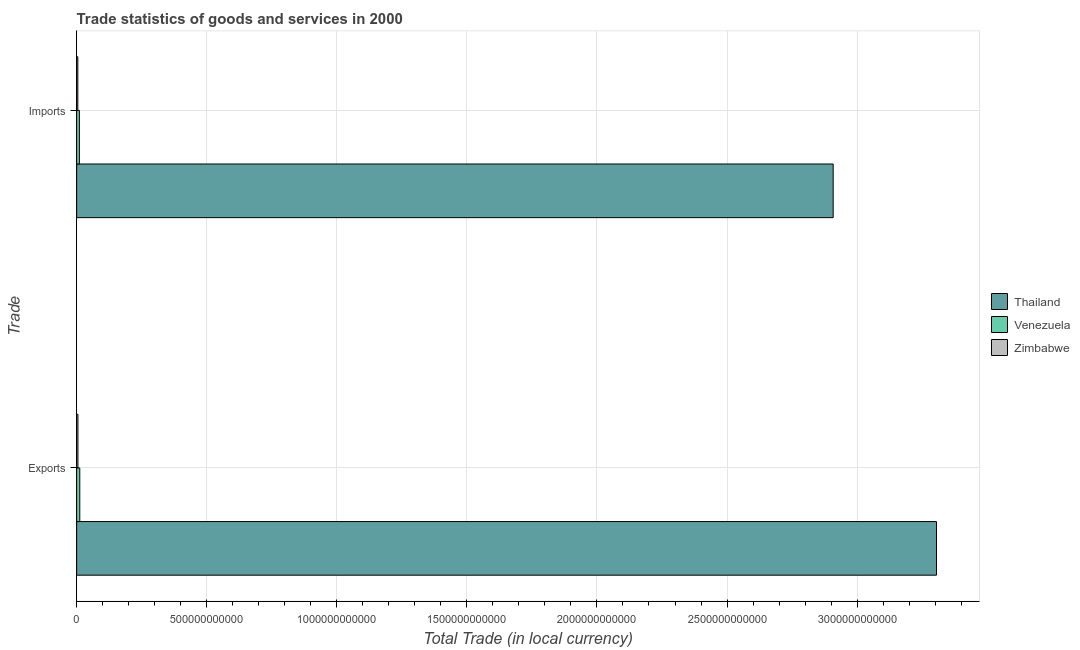How many different coloured bars are there?
Your response must be concise. 3. How many groups of bars are there?
Your response must be concise. 2. Are the number of bars on each tick of the Y-axis equal?
Your answer should be compact. Yes. How many bars are there on the 1st tick from the top?
Ensure brevity in your answer.  3. How many bars are there on the 2nd tick from the bottom?
Your answer should be very brief. 3. What is the label of the 2nd group of bars from the top?
Your answer should be very brief. Exports. What is the export of goods and services in Venezuela?
Make the answer very short. 1.20e+1. Across all countries, what is the maximum export of goods and services?
Your answer should be very brief. 3.31e+12. Across all countries, what is the minimum imports of goods and services?
Provide a short and direct response. 4.42e+09. In which country was the export of goods and services maximum?
Keep it short and to the point. Thailand. In which country was the imports of goods and services minimum?
Your answer should be very brief. Zimbabwe. What is the total export of goods and services in the graph?
Provide a succinct answer. 3.32e+12. What is the difference between the imports of goods and services in Venezuela and that in Thailand?
Your answer should be very brief. -2.90e+12. What is the difference between the imports of goods and services in Thailand and the export of goods and services in Venezuela?
Make the answer very short. 2.90e+12. What is the average imports of goods and services per country?
Give a very brief answer. 9.74e+11. What is the difference between the export of goods and services and imports of goods and services in Venezuela?
Offer a very short reply. 1.51e+09. In how many countries, is the imports of goods and services greater than 1500000000000 LCU?
Your response must be concise. 1. What is the ratio of the imports of goods and services in Thailand to that in Venezuela?
Ensure brevity in your answer.  278.09. Is the export of goods and services in Venezuela less than that in Thailand?
Your response must be concise. Yes. What does the 3rd bar from the top in Imports represents?
Provide a succinct answer. Thailand. What does the 2nd bar from the bottom in Imports represents?
Provide a succinct answer. Venezuela. How many bars are there?
Make the answer very short. 6. Are all the bars in the graph horizontal?
Your answer should be compact. Yes. How many countries are there in the graph?
Offer a terse response. 3. What is the difference between two consecutive major ticks on the X-axis?
Offer a very short reply. 5.00e+11. Does the graph contain any zero values?
Keep it short and to the point. No. Does the graph contain grids?
Make the answer very short. Yes. What is the title of the graph?
Give a very brief answer. Trade statistics of goods and services in 2000. What is the label or title of the X-axis?
Give a very brief answer. Total Trade (in local currency). What is the label or title of the Y-axis?
Offer a terse response. Trade. What is the Total Trade (in local currency) of Thailand in Exports?
Offer a terse response. 3.31e+12. What is the Total Trade (in local currency) in Venezuela in Exports?
Provide a succinct answer. 1.20e+1. What is the Total Trade (in local currency) of Zimbabwe in Exports?
Offer a terse response. 4.88e+09. What is the Total Trade (in local currency) of Thailand in Imports?
Offer a very short reply. 2.91e+12. What is the Total Trade (in local currency) of Venezuela in Imports?
Provide a short and direct response. 1.05e+1. What is the Total Trade (in local currency) in Zimbabwe in Imports?
Your answer should be very brief. 4.42e+09. Across all Trade, what is the maximum Total Trade (in local currency) of Thailand?
Make the answer very short. 3.31e+12. Across all Trade, what is the maximum Total Trade (in local currency) of Venezuela?
Offer a very short reply. 1.20e+1. Across all Trade, what is the maximum Total Trade (in local currency) of Zimbabwe?
Provide a succinct answer. 4.88e+09. Across all Trade, what is the minimum Total Trade (in local currency) in Thailand?
Give a very brief answer. 2.91e+12. Across all Trade, what is the minimum Total Trade (in local currency) of Venezuela?
Offer a very short reply. 1.05e+1. Across all Trade, what is the minimum Total Trade (in local currency) of Zimbabwe?
Your answer should be very brief. 4.42e+09. What is the total Total Trade (in local currency) in Thailand in the graph?
Give a very brief answer. 6.21e+12. What is the total Total Trade (in local currency) in Venezuela in the graph?
Provide a succinct answer. 2.24e+1. What is the total Total Trade (in local currency) in Zimbabwe in the graph?
Your answer should be very brief. 9.29e+09. What is the difference between the Total Trade (in local currency) in Thailand in Exports and that in Imports?
Provide a short and direct response. 3.97e+11. What is the difference between the Total Trade (in local currency) of Venezuela in Exports and that in Imports?
Offer a terse response. 1.51e+09. What is the difference between the Total Trade (in local currency) in Zimbabwe in Exports and that in Imports?
Provide a succinct answer. 4.59e+08. What is the difference between the Total Trade (in local currency) in Thailand in Exports and the Total Trade (in local currency) in Venezuela in Imports?
Offer a very short reply. 3.29e+12. What is the difference between the Total Trade (in local currency) in Thailand in Exports and the Total Trade (in local currency) in Zimbabwe in Imports?
Your answer should be compact. 3.30e+12. What is the difference between the Total Trade (in local currency) of Venezuela in Exports and the Total Trade (in local currency) of Zimbabwe in Imports?
Provide a succinct answer. 7.55e+09. What is the average Total Trade (in local currency) in Thailand per Trade?
Your response must be concise. 3.11e+12. What is the average Total Trade (in local currency) in Venezuela per Trade?
Give a very brief answer. 1.12e+1. What is the average Total Trade (in local currency) of Zimbabwe per Trade?
Your answer should be very brief. 4.65e+09. What is the difference between the Total Trade (in local currency) of Thailand and Total Trade (in local currency) of Venezuela in Exports?
Give a very brief answer. 3.29e+12. What is the difference between the Total Trade (in local currency) in Thailand and Total Trade (in local currency) in Zimbabwe in Exports?
Your answer should be compact. 3.30e+12. What is the difference between the Total Trade (in local currency) of Venezuela and Total Trade (in local currency) of Zimbabwe in Exports?
Offer a terse response. 7.09e+09. What is the difference between the Total Trade (in local currency) in Thailand and Total Trade (in local currency) in Venezuela in Imports?
Offer a very short reply. 2.90e+12. What is the difference between the Total Trade (in local currency) in Thailand and Total Trade (in local currency) in Zimbabwe in Imports?
Your answer should be compact. 2.90e+12. What is the difference between the Total Trade (in local currency) in Venezuela and Total Trade (in local currency) in Zimbabwe in Imports?
Offer a very short reply. 6.04e+09. What is the ratio of the Total Trade (in local currency) of Thailand in Exports to that in Imports?
Provide a short and direct response. 1.14. What is the ratio of the Total Trade (in local currency) of Venezuela in Exports to that in Imports?
Offer a terse response. 1.14. What is the ratio of the Total Trade (in local currency) of Zimbabwe in Exports to that in Imports?
Your answer should be compact. 1.1. What is the difference between the highest and the second highest Total Trade (in local currency) in Thailand?
Your answer should be compact. 3.97e+11. What is the difference between the highest and the second highest Total Trade (in local currency) in Venezuela?
Your answer should be compact. 1.51e+09. What is the difference between the highest and the second highest Total Trade (in local currency) in Zimbabwe?
Ensure brevity in your answer.  4.59e+08. What is the difference between the highest and the lowest Total Trade (in local currency) in Thailand?
Offer a very short reply. 3.97e+11. What is the difference between the highest and the lowest Total Trade (in local currency) of Venezuela?
Provide a succinct answer. 1.51e+09. What is the difference between the highest and the lowest Total Trade (in local currency) in Zimbabwe?
Your answer should be very brief. 4.59e+08. 